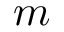Convert formula to latex. <formula><loc_0><loc_0><loc_500><loc_500>m</formula> 